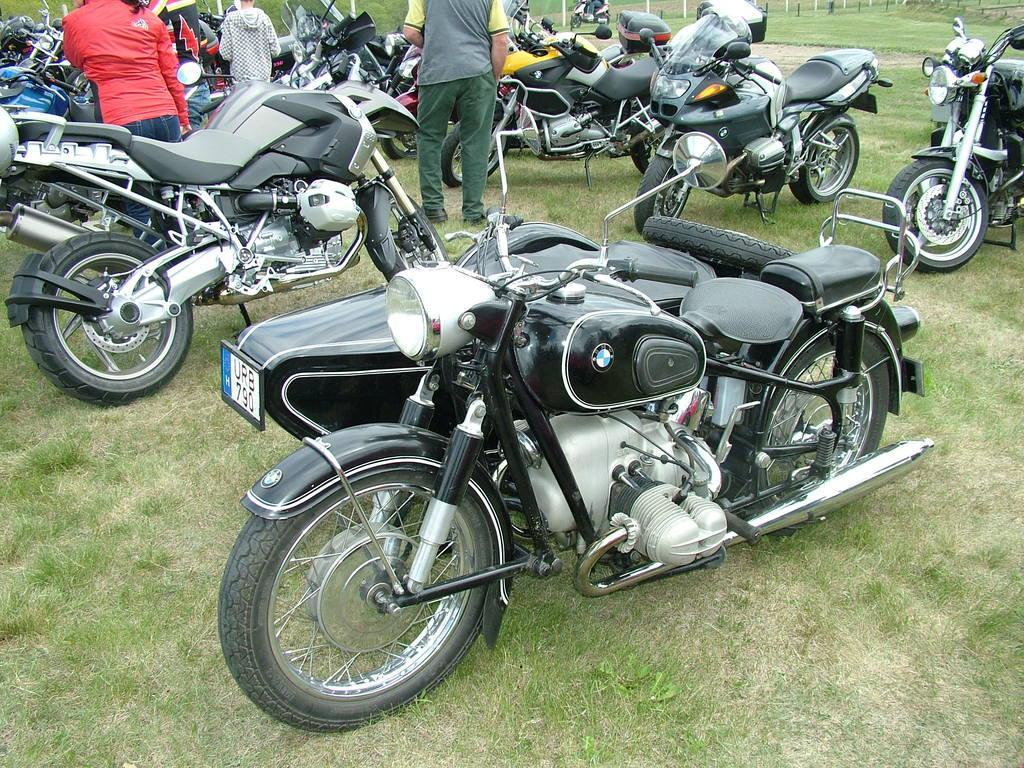Could you give a brief overview of what you see in this image? There are four persons and this is grass. Here we can see bikes. 